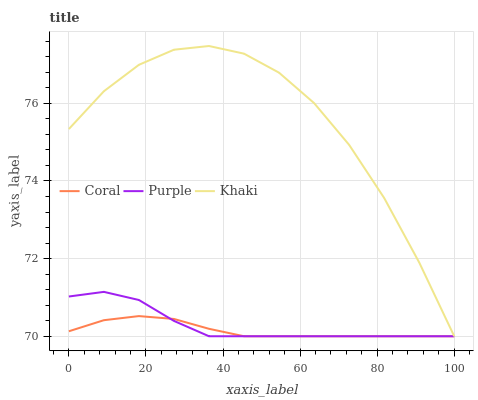Does Coral have the minimum area under the curve?
Answer yes or no. Yes. Does Khaki have the maximum area under the curve?
Answer yes or no. Yes. Does Khaki have the minimum area under the curve?
Answer yes or no. No. Does Coral have the maximum area under the curve?
Answer yes or no. No. Is Coral the smoothest?
Answer yes or no. Yes. Is Khaki the roughest?
Answer yes or no. Yes. Is Khaki the smoothest?
Answer yes or no. No. Is Coral the roughest?
Answer yes or no. No. Does Purple have the lowest value?
Answer yes or no. Yes. Does Khaki have the highest value?
Answer yes or no. Yes. Does Coral have the highest value?
Answer yes or no. No. Does Coral intersect Purple?
Answer yes or no. Yes. Is Coral less than Purple?
Answer yes or no. No. Is Coral greater than Purple?
Answer yes or no. No. 